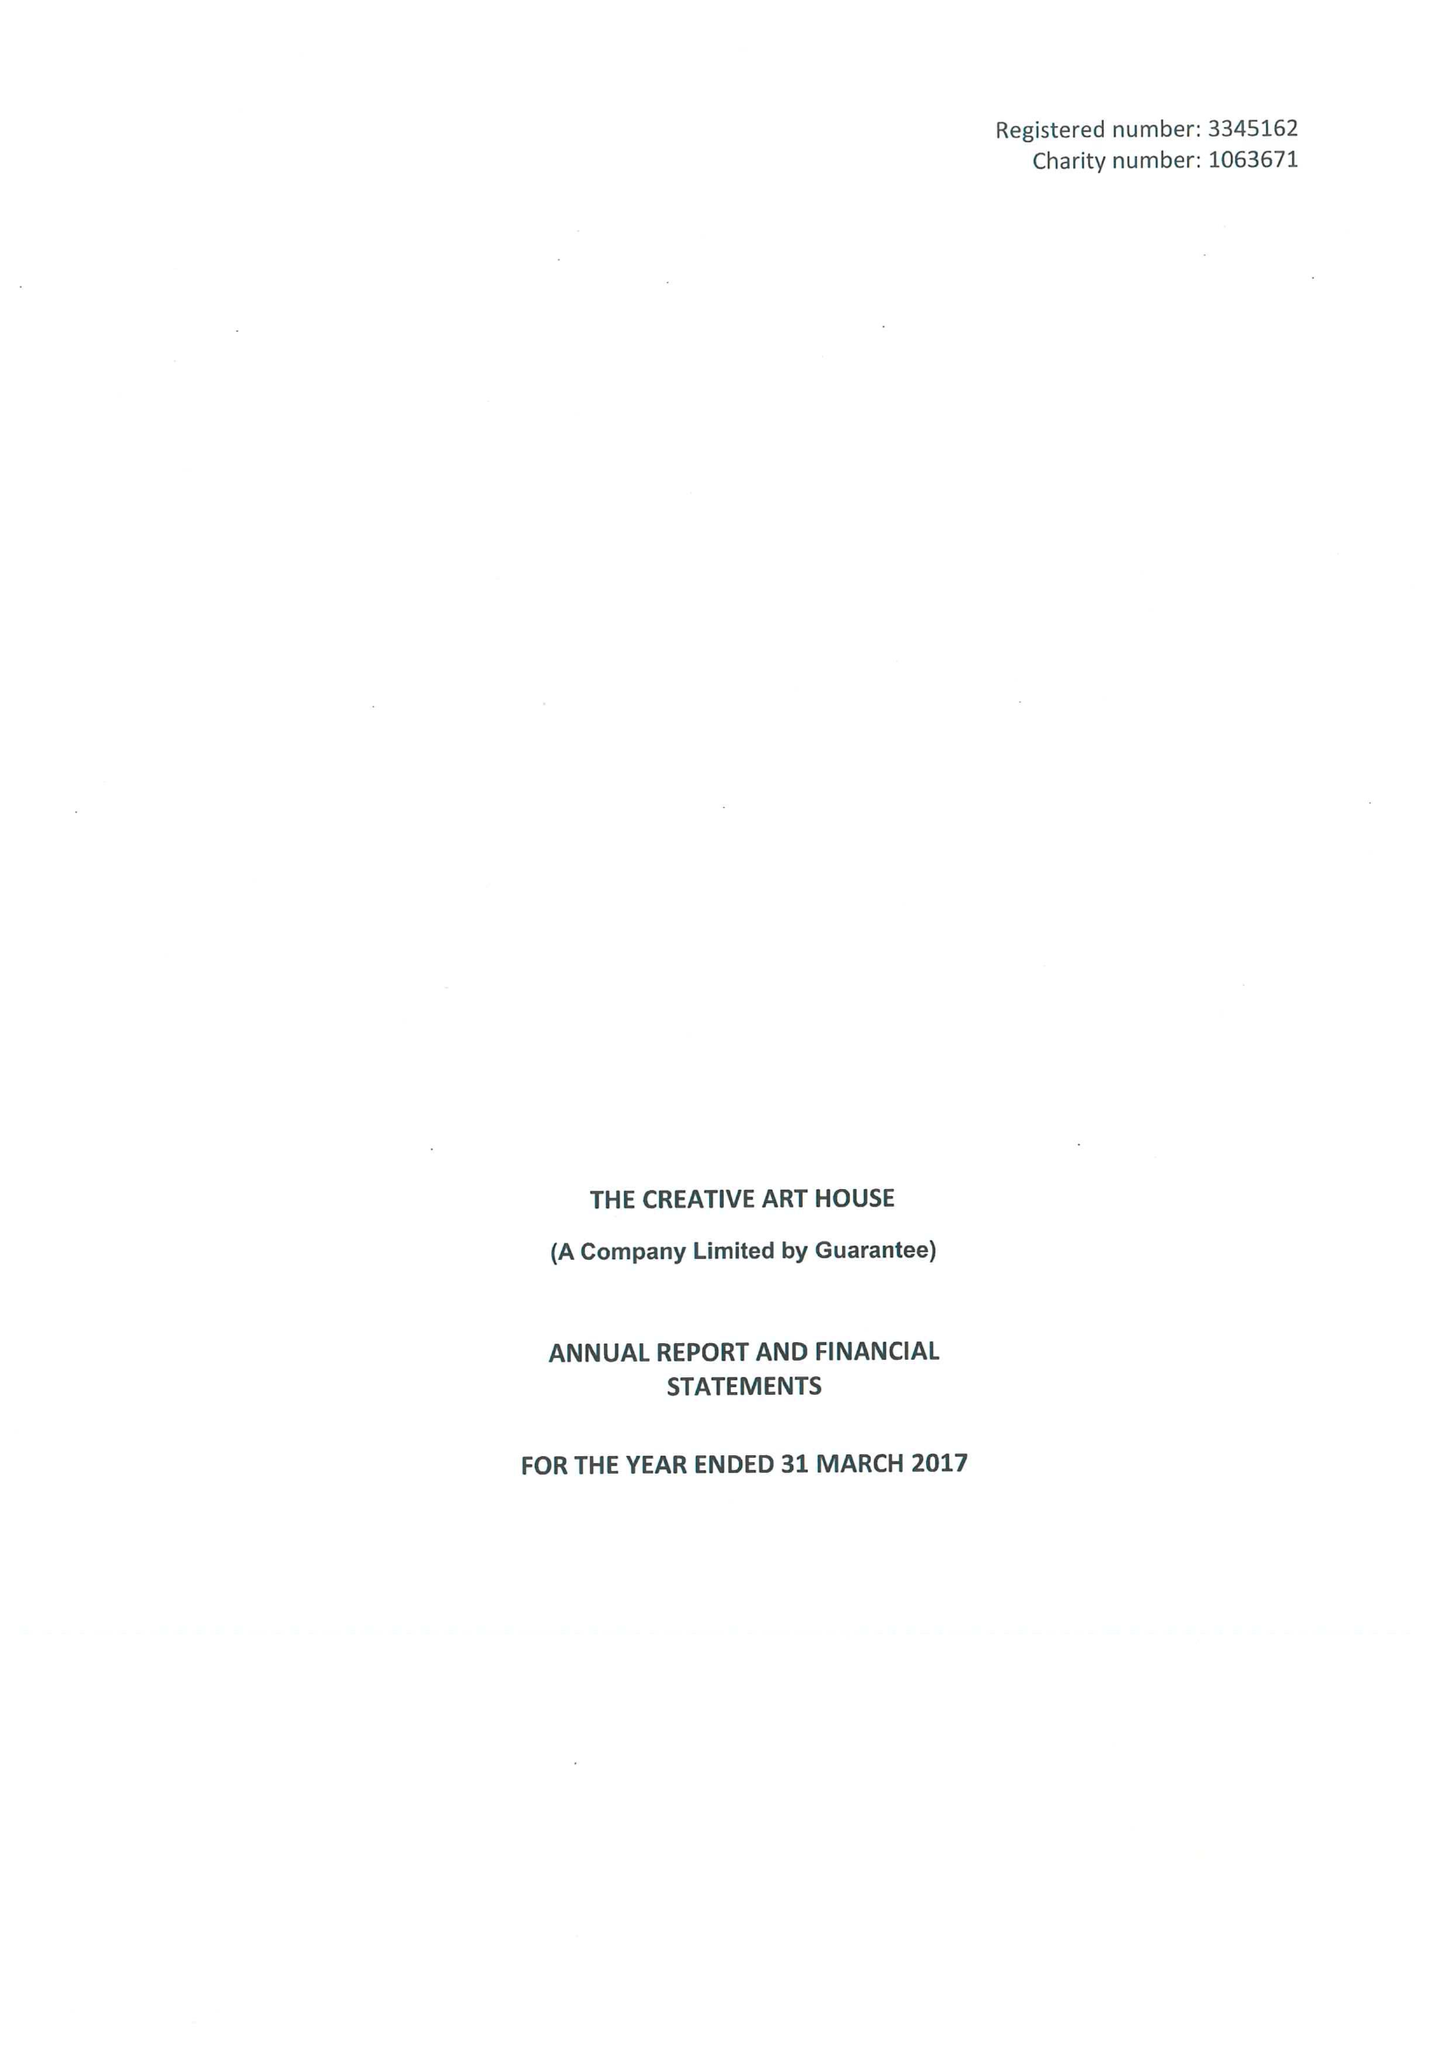What is the value for the charity_number?
Answer the question using a single word or phrase. 1063671 